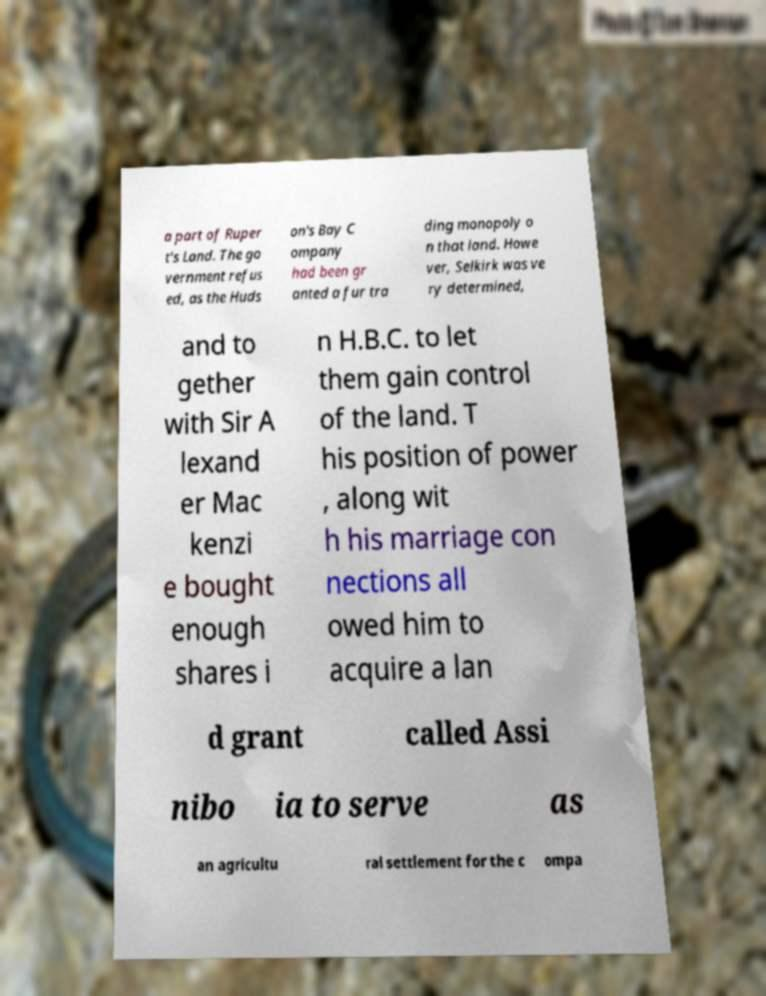Could you assist in decoding the text presented in this image and type it out clearly? a part of Ruper t's Land. The go vernment refus ed, as the Huds on's Bay C ompany had been gr anted a fur tra ding monopoly o n that land. Howe ver, Selkirk was ve ry determined, and to gether with Sir A lexand er Mac kenzi e bought enough shares i n H.B.C. to let them gain control of the land. T his position of power , along wit h his marriage con nections all owed him to acquire a lan d grant called Assi nibo ia to serve as an agricultu ral settlement for the c ompa 